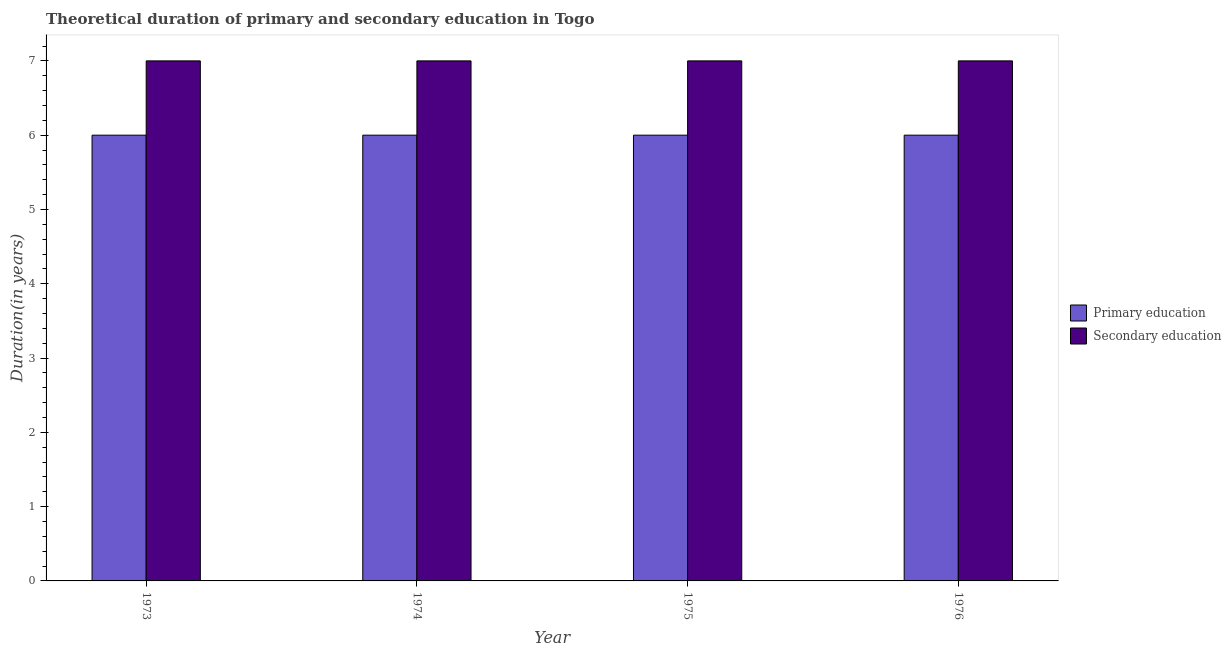Are the number of bars per tick equal to the number of legend labels?
Give a very brief answer. Yes. Are the number of bars on each tick of the X-axis equal?
Keep it short and to the point. Yes. How many bars are there on the 2nd tick from the left?
Offer a terse response. 2. How many bars are there on the 3rd tick from the right?
Your response must be concise. 2. What is the label of the 2nd group of bars from the left?
Ensure brevity in your answer.  1974. What is the duration of primary education in 1975?
Ensure brevity in your answer.  6. Across all years, what is the maximum duration of primary education?
Your answer should be compact. 6. Across all years, what is the minimum duration of secondary education?
Give a very brief answer. 7. What is the total duration of secondary education in the graph?
Provide a succinct answer. 28. What is the difference between the duration of secondary education in 1973 and that in 1976?
Give a very brief answer. 0. What is the difference between the duration of secondary education in 1973 and the duration of primary education in 1974?
Your answer should be very brief. 0. What is the average duration of secondary education per year?
Your response must be concise. 7. In how many years, is the duration of primary education greater than 4.6 years?
Offer a terse response. 4. Is the duration of primary education in 1973 less than that in 1974?
Keep it short and to the point. No. What is the difference between the highest and the second highest duration of secondary education?
Offer a very short reply. 0. What is the difference between the highest and the lowest duration of primary education?
Your response must be concise. 0. In how many years, is the duration of secondary education greater than the average duration of secondary education taken over all years?
Make the answer very short. 0. Is the sum of the duration of secondary education in 1974 and 1976 greater than the maximum duration of primary education across all years?
Provide a succinct answer. Yes. What does the 2nd bar from the left in 1976 represents?
Make the answer very short. Secondary education. What does the 1st bar from the right in 1973 represents?
Your answer should be very brief. Secondary education. How many bars are there?
Your response must be concise. 8. What is the difference between two consecutive major ticks on the Y-axis?
Offer a terse response. 1. Does the graph contain any zero values?
Offer a terse response. No. Where does the legend appear in the graph?
Provide a short and direct response. Center right. What is the title of the graph?
Your response must be concise. Theoretical duration of primary and secondary education in Togo. What is the label or title of the X-axis?
Offer a terse response. Year. What is the label or title of the Y-axis?
Your answer should be compact. Duration(in years). What is the Duration(in years) in Secondary education in 1973?
Offer a very short reply. 7. What is the Duration(in years) of Secondary education in 1974?
Offer a very short reply. 7. What is the Duration(in years) in Primary education in 1976?
Your response must be concise. 6. Across all years, what is the maximum Duration(in years) in Primary education?
Your answer should be very brief. 6. Across all years, what is the minimum Duration(in years) of Primary education?
Your answer should be compact. 6. What is the difference between the Duration(in years) of Secondary education in 1973 and that in 1974?
Provide a short and direct response. 0. What is the difference between the Duration(in years) of Primary education in 1973 and that in 1976?
Your answer should be very brief. 0. What is the difference between the Duration(in years) in Primary education in 1974 and that in 1976?
Offer a terse response. 0. What is the difference between the Duration(in years) in Primary education in 1973 and the Duration(in years) in Secondary education in 1974?
Your answer should be compact. -1. What is the difference between the Duration(in years) in Primary education in 1973 and the Duration(in years) in Secondary education in 1975?
Your answer should be compact. -1. What is the difference between the Duration(in years) of Primary education in 1974 and the Duration(in years) of Secondary education in 1975?
Give a very brief answer. -1. What is the average Duration(in years) in Secondary education per year?
Your answer should be compact. 7. In the year 1974, what is the difference between the Duration(in years) of Primary education and Duration(in years) of Secondary education?
Your answer should be very brief. -1. What is the ratio of the Duration(in years) in Primary education in 1973 to that in 1974?
Your answer should be compact. 1. What is the ratio of the Duration(in years) of Primary education in 1973 to that in 1975?
Keep it short and to the point. 1. What is the ratio of the Duration(in years) of Primary education in 1973 to that in 1976?
Keep it short and to the point. 1. What is the ratio of the Duration(in years) in Secondary education in 1974 to that in 1975?
Offer a terse response. 1. What is the difference between the highest and the second highest Duration(in years) in Secondary education?
Your answer should be very brief. 0. What is the difference between the highest and the lowest Duration(in years) in Primary education?
Your response must be concise. 0. What is the difference between the highest and the lowest Duration(in years) in Secondary education?
Give a very brief answer. 0. 